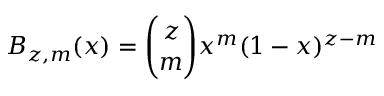Convert formula to latex. <formula><loc_0><loc_0><loc_500><loc_500>B _ { z , m } ( x ) = \binom { z } { m } x ^ { m } ( 1 - x ) ^ { z - m }</formula> 